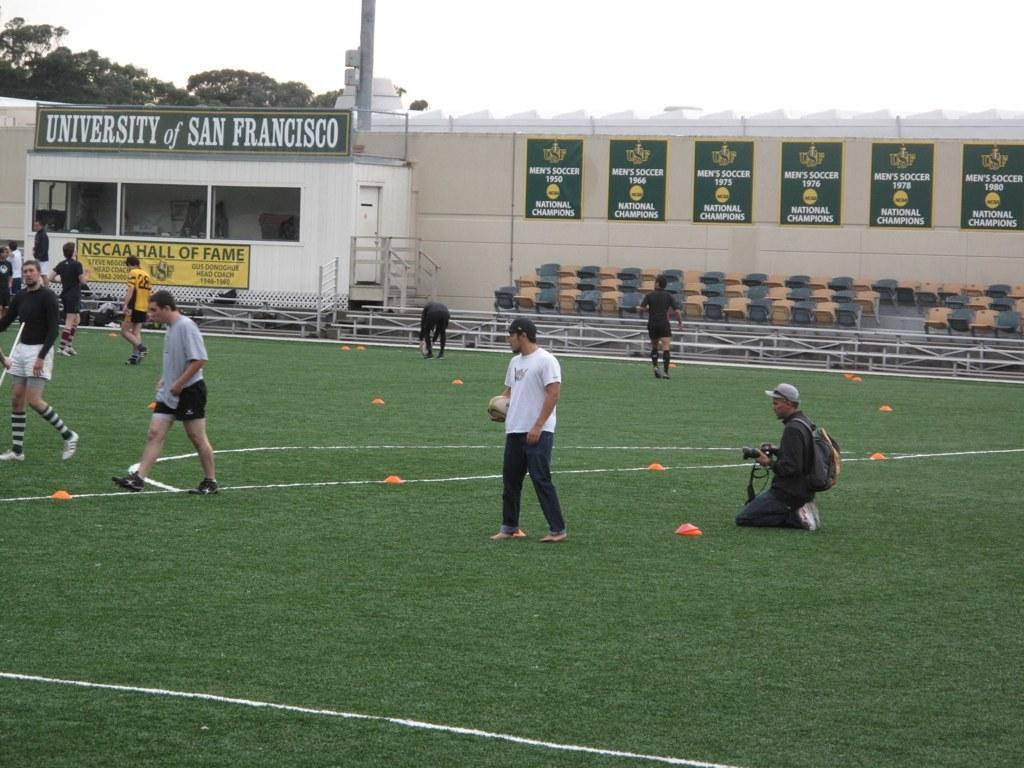Provide a one-sentence caption for the provided image. At the University of San Francisco a group of players practice on the soccer field. 